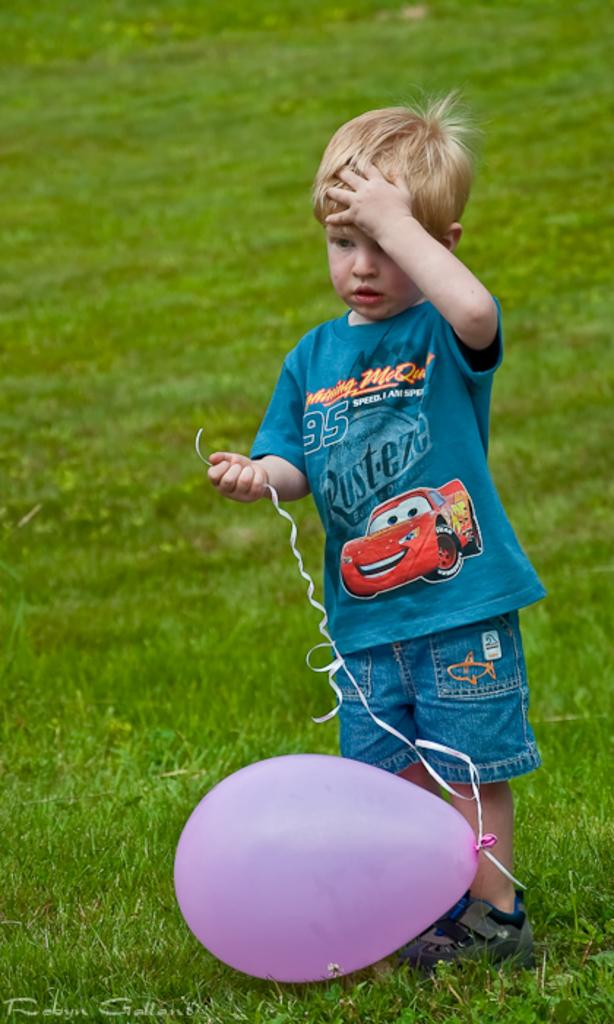Who is present in the image? There is a boy in the image. What is the boy holding in his hand? The boy is holding a thread in his hand. What is the thread connected to? The thread is attached to a balloon. What type of surface is visible behind the boy? There is grass visible behind the boy. What type of music can be heard coming from the crate in the image? There is no crate present in the image, so it is not possible to determine what type of music might be heard. 